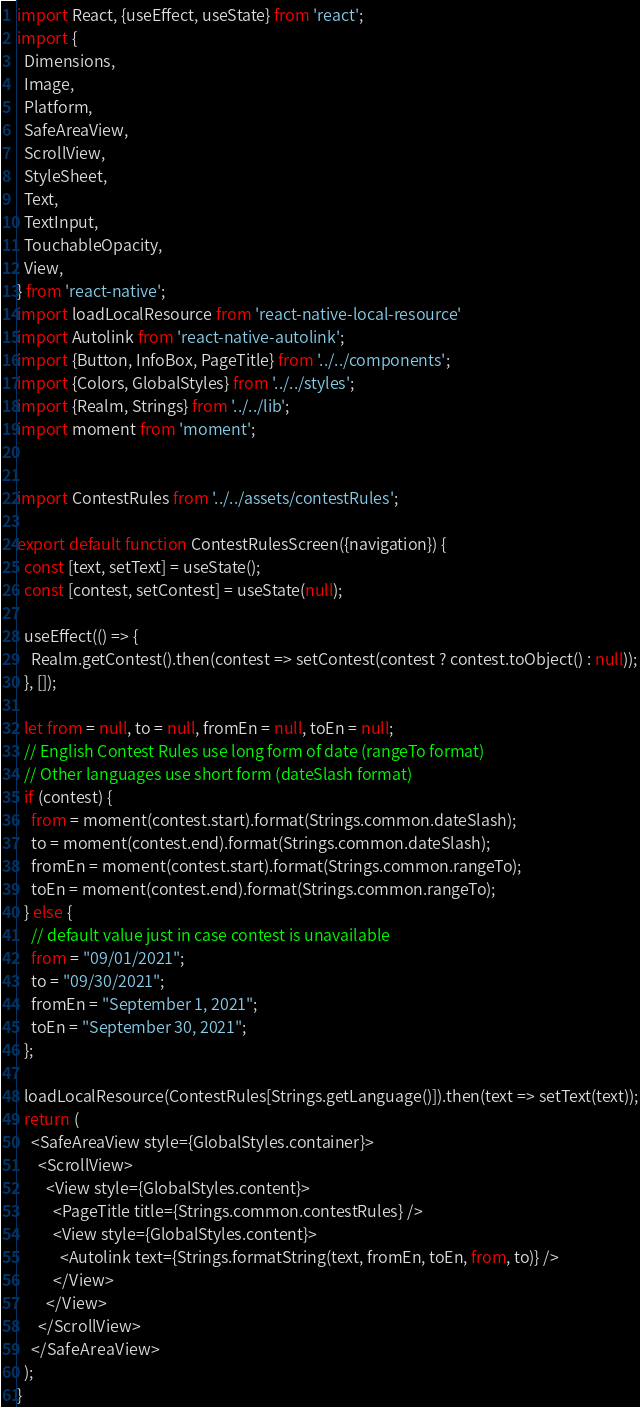<code> <loc_0><loc_0><loc_500><loc_500><_JavaScript_>import React, {useEffect, useState} from 'react';
import {
  Dimensions,
  Image,
  Platform,
  SafeAreaView,
  ScrollView,
  StyleSheet,
  Text,
  TextInput,
  TouchableOpacity,
  View,
} from 'react-native';
import loadLocalResource from 'react-native-local-resource'
import Autolink from 'react-native-autolink';
import {Button, InfoBox, PageTitle} from '../../components';
import {Colors, GlobalStyles} from '../../styles';
import {Realm, Strings} from '../../lib';
import moment from 'moment';


import ContestRules from '../../assets/contestRules';

export default function ContestRulesScreen({navigation}) {
  const [text, setText] = useState();
  const [contest, setContest] = useState(null);

  useEffect(() => {
    Realm.getContest().then(contest => setContest(contest ? contest.toObject() : null));
  }, []);

  let from = null, to = null, fromEn = null, toEn = null;
  // English Contest Rules use long form of date (rangeTo format)
  // Other languages use short form (dateSlash format)
  if (contest) {
    from = moment(contest.start).format(Strings.common.dateSlash);
    to = moment(contest.end).format(Strings.common.dateSlash);
    fromEn = moment(contest.start).format(Strings.common.rangeTo);
    toEn = moment(contest.end).format(Strings.common.rangeTo);
  } else {
    // default value just in case contest is unavailable
    from = "09/01/2021";
    to = "09/30/2021";
    fromEn = "September 1, 2021";
    toEn = "September 30, 2021";
  };
 
  loadLocalResource(ContestRules[Strings.getLanguage()]).then(text => setText(text));
  return (
    <SafeAreaView style={GlobalStyles.container}>
      <ScrollView>
        <View style={GlobalStyles.content}>
          <PageTitle title={Strings.common.contestRules} />
          <View style={GlobalStyles.content}>
            <Autolink text={Strings.formatString(text, fromEn, toEn, from, to)} />
          </View>
        </View>
      </ScrollView>
    </SafeAreaView>
  );
}
</code> 